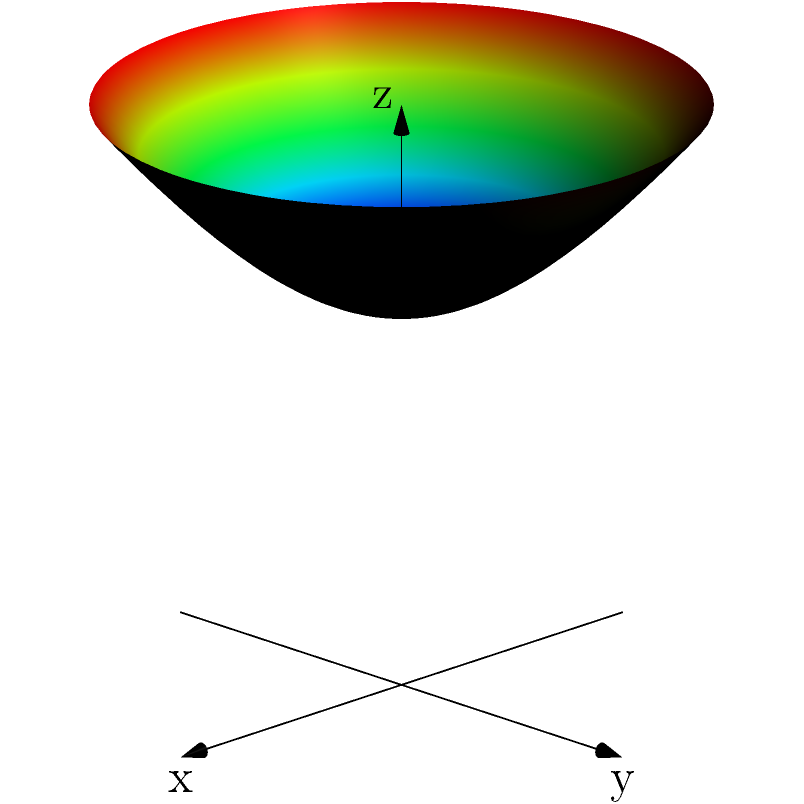Consider a hyperbolic surface resembling an optimized wind turbine blade, described by the parametric equations:

$$x = 2\sinh(u)\cos(v)$$
$$y = 2\sinh(u)\sin(v)$$
$$z = 2\cosh(u)$$

where $0 \leq u \leq 1$ and $0 \leq v \leq 2\pi$. Calculate the Gaussian curvature $K$ at the point $(0, 0, 2)$ on this surface. To calculate the Gaussian curvature, we'll follow these steps:

1) The Gaussian curvature $K$ is given by $K = \frac{LN - M^2}{EG - F^2}$, where $E$, $F$, $G$ are the coefficients of the first fundamental form, and $L$, $M$, $N$ are the coefficients of the second fundamental form.

2) First, let's calculate the partial derivatives:
   $\mathbf{r}_u = (2\cosh(u)\cos(v), 2\cosh(u)\sin(v), 2\sinh(u))$
   $\mathbf{r}_v = (-2\sinh(u)\sin(v), 2\sinh(u)\cos(v), 0)$
   $\mathbf{r}_{uu} = (2\sinh(u)\cos(v), 2\sinh(u)\sin(v), 2\cosh(u))$
   $\mathbf{r}_{uv} = (-2\cosh(u)\sin(v), 2\cosh(u)\cos(v), 0)$
   $\mathbf{r}_{vv} = (-2\sinh(u)\cos(v), -2\sinh(u)\sin(v), 0)$

3) Calculate $E$, $F$, and $G$:
   $E = \mathbf{r}_u \cdot \mathbf{r}_u = 4\cosh^2(u)$
   $F = \mathbf{r}_u \cdot \mathbf{r}_v = 0$
   $G = \mathbf{r}_v \cdot \mathbf{r}_v = 4\sinh^2(u)$

4) Calculate the unit normal vector:
   $\mathbf{N} = \frac{\mathbf{r}_u \times \mathbf{r}_v}{|\mathbf{r}_u \times \mathbf{r}_v|} = \frac{(-2\cos(v), -2\sin(v), 2)}{\sqrt{4\cosh^2(u) + 4}}$

5) Calculate $L$, $M$, and $N$:
   $L = \mathbf{r}_{uu} \cdot \mathbf{N} = -\frac{4}{\sqrt{4\cosh^2(u) + 4}}$
   $M = \mathbf{r}_{uv} \cdot \mathbf{N} = 0$
   $N = \mathbf{r}_{vv} \cdot \mathbf{N} = \frac{4\sinh^2(u)}{\sqrt{4\cosh^2(u) + 4}}$

6) The point $(0, 0, 2)$ corresponds to $u = 0$ and $v = 0$. Substituting these values:
   $E = 4$, $F = 0$, $G = 0$
   $L = -1$, $M = 0$, $N = 0$

7) Calculate the Gaussian curvature:
   $K = \frac{LN - M^2}{EG - F^2} = \frac{(-1)(0) - 0^2}{(4)(0) - 0^2} = 0$

Therefore, the Gaussian curvature at the point $(0, 0, 2)$ is 0.
Answer: $K = 0$ 